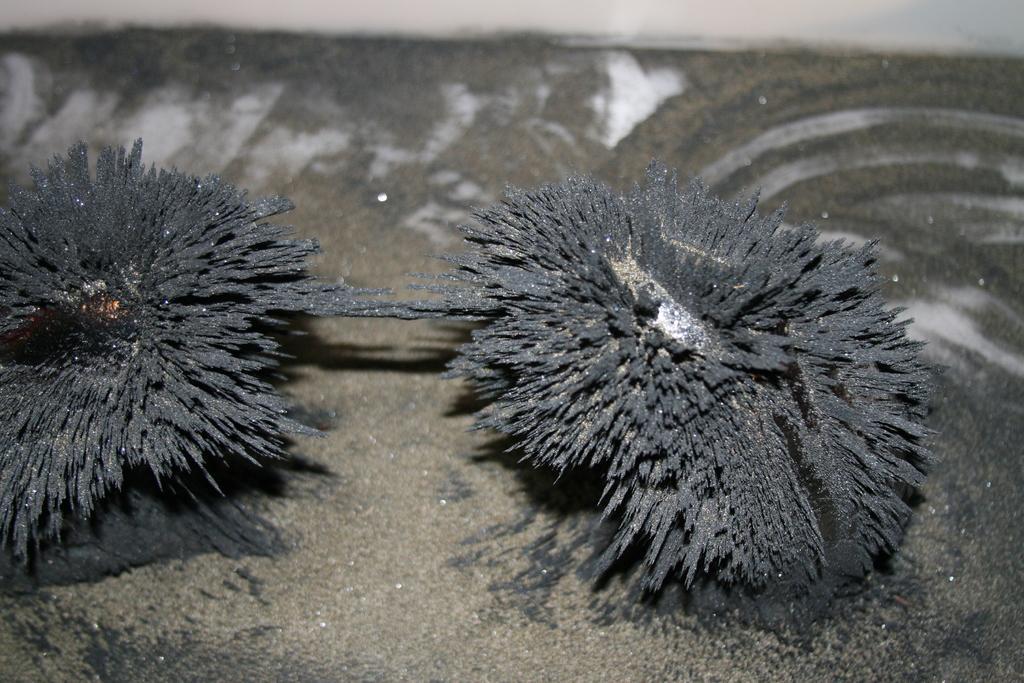How would you summarize this image in a sentence or two? In this image I can see the magnet and the black color object which is sticking to each other. It is on the ash color surface. 